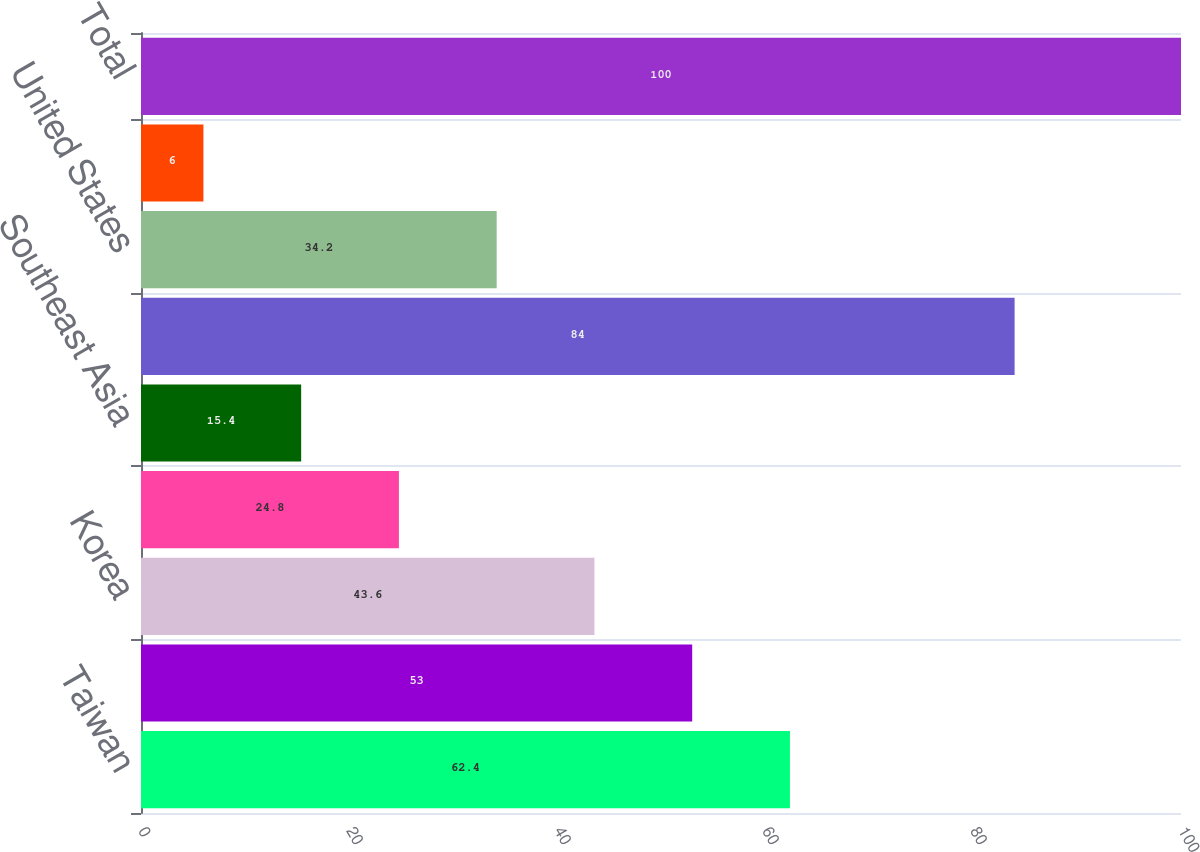Convert chart to OTSL. <chart><loc_0><loc_0><loc_500><loc_500><bar_chart><fcel>Taiwan<fcel>China<fcel>Korea<fcel>Japan<fcel>Southeast Asia<fcel>Asia Pacific<fcel>United States<fcel>Europe<fcel>Total<nl><fcel>62.4<fcel>53<fcel>43.6<fcel>24.8<fcel>15.4<fcel>84<fcel>34.2<fcel>6<fcel>100<nl></chart> 